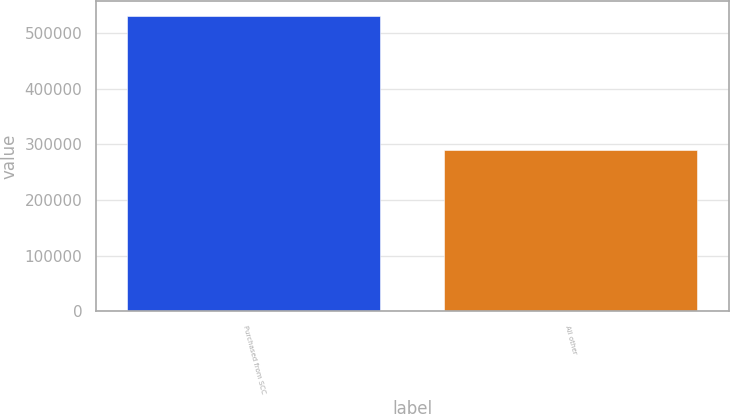Convert chart. <chart><loc_0><loc_0><loc_500><loc_500><bar_chart><fcel>Purchased from SCC<fcel>All other<nl><fcel>531233<fcel>290604<nl></chart> 